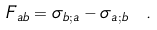<formula> <loc_0><loc_0><loc_500><loc_500>F _ { a b } = \sigma _ { b ; a } - \sigma _ { a ; b } \ .</formula> 